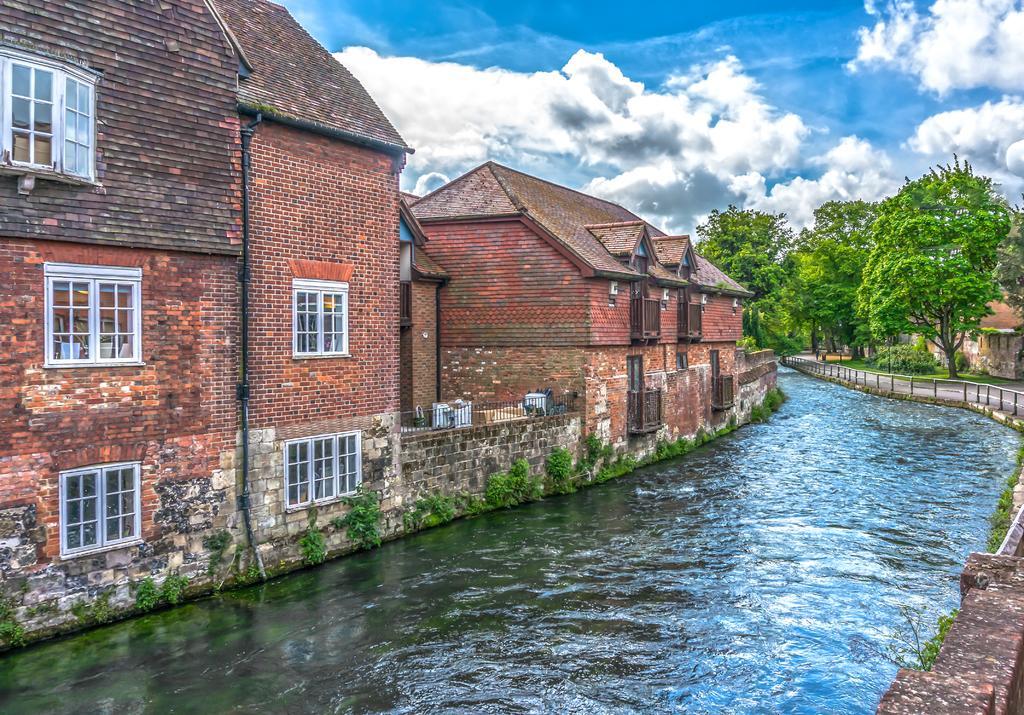Could you give a brief overview of what you see in this image? In this image we can see the water flowing, brick buildings, trees, fence and the blue color of sky with clouds in the background. 